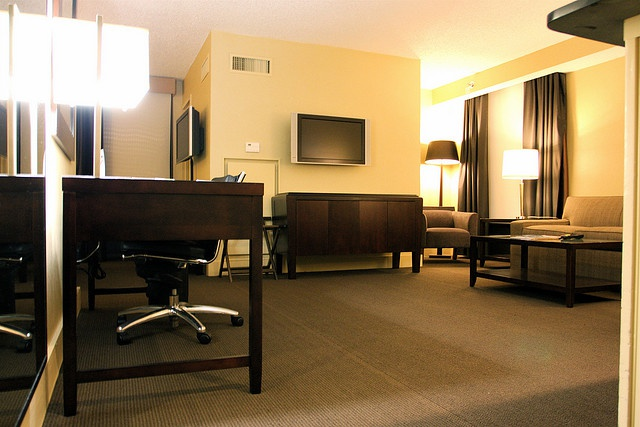Describe the objects in this image and their specific colors. I can see chair in tan, black, olive, and gray tones, couch in tan, black, olive, orange, and maroon tones, tv in tan, olive, and black tones, chair in tan, black, maroon, olive, and orange tones, and couch in tan, black, maroon, and brown tones in this image. 